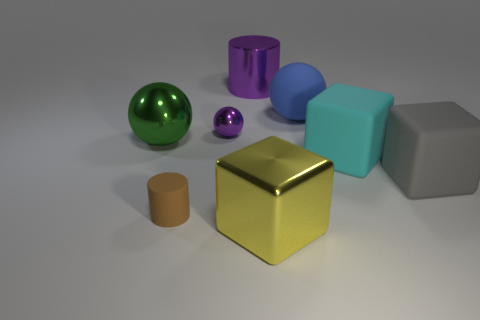How many objects are shiny things left of the metal block or large things that are behind the large blue ball?
Provide a succinct answer. 3. The green metallic thing that is the same size as the yellow thing is what shape?
Ensure brevity in your answer.  Sphere. What is the shape of the tiny purple metallic thing that is left of the big cyan object in front of the ball to the right of the large yellow metal cube?
Ensure brevity in your answer.  Sphere. Are there the same number of cyan cubes that are behind the cyan matte thing and large yellow matte spheres?
Give a very brief answer. Yes. Does the brown cylinder have the same size as the yellow block?
Ensure brevity in your answer.  No. What number of matte things are purple balls or small blocks?
Give a very brief answer. 0. There is a cylinder that is the same size as the purple shiny ball; what material is it?
Make the answer very short. Rubber. How many other things are there of the same material as the gray block?
Provide a succinct answer. 3. Is the number of cyan objects in front of the large gray rubber object less than the number of small metal spheres?
Provide a succinct answer. Yes. Is the shape of the large cyan thing the same as the brown matte thing?
Your response must be concise. No. 